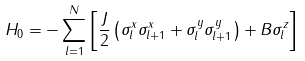<formula> <loc_0><loc_0><loc_500><loc_500>H _ { 0 } = - \sum _ { l = 1 } ^ { N } \left [ \frac { J } { 2 } \left ( \sigma _ { l } ^ { x } \sigma _ { l + 1 } ^ { x } + \sigma _ { l } ^ { y } \sigma _ { l + 1 } ^ { y } \right ) + B \sigma _ { l } ^ { z } \right ]</formula> 